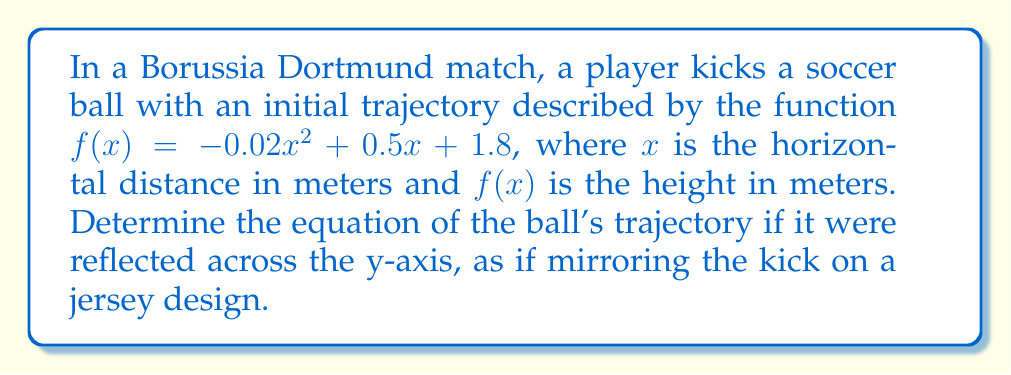Teach me how to tackle this problem. To reflect a function across the y-axis, we replace every $x$ with $-x$ in the original function. Let's go through this step-by-step:

1) The original function is:
   $f(x) = -0.02x^2 + 0.5x + 1.8$

2) Replace every $x$ with $-x$:
   $f(-x) = -0.02(-x)^2 + 0.5(-x) + 1.8$

3) Simplify:
   $f(-x) = -0.02x^2 - 0.5x + 1.8$

4) The new function, let's call it $g(x)$, is:
   $g(x) = -0.02x^2 - 0.5x + 1.8$

Note that the $x^2$ term remains unchanged because $(-x)^2 = x^2$, but the linear term $0.5x$ becomes $-0.5x$. The constant term remains the same.

This new function $g(x)$ represents the trajectory of the ball reflected across the y-axis, creating a mirror image of the original kick.
Answer: $g(x) = -0.02x^2 - 0.5x + 1.8$ 